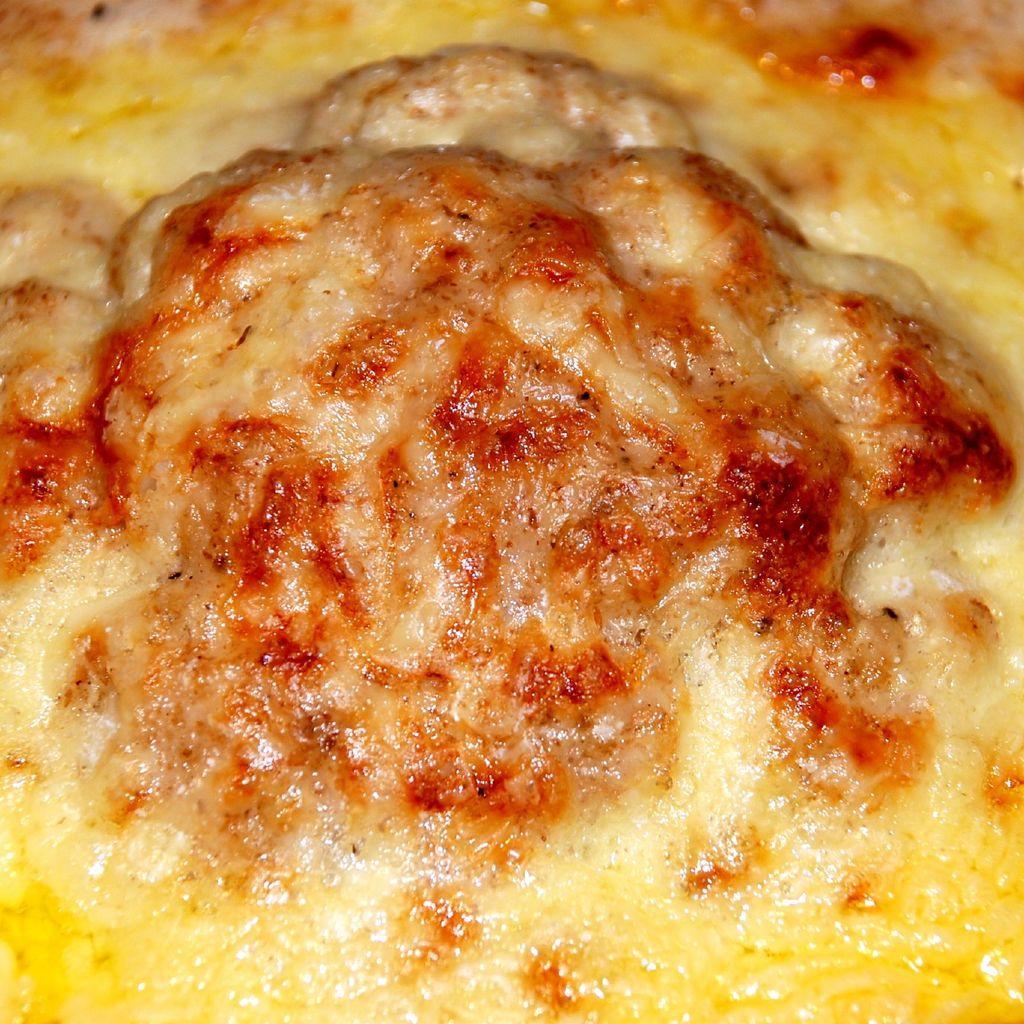How would you summarize this image in a sentence or two? In this image I can see the food which is in yellow, cream and red color. 